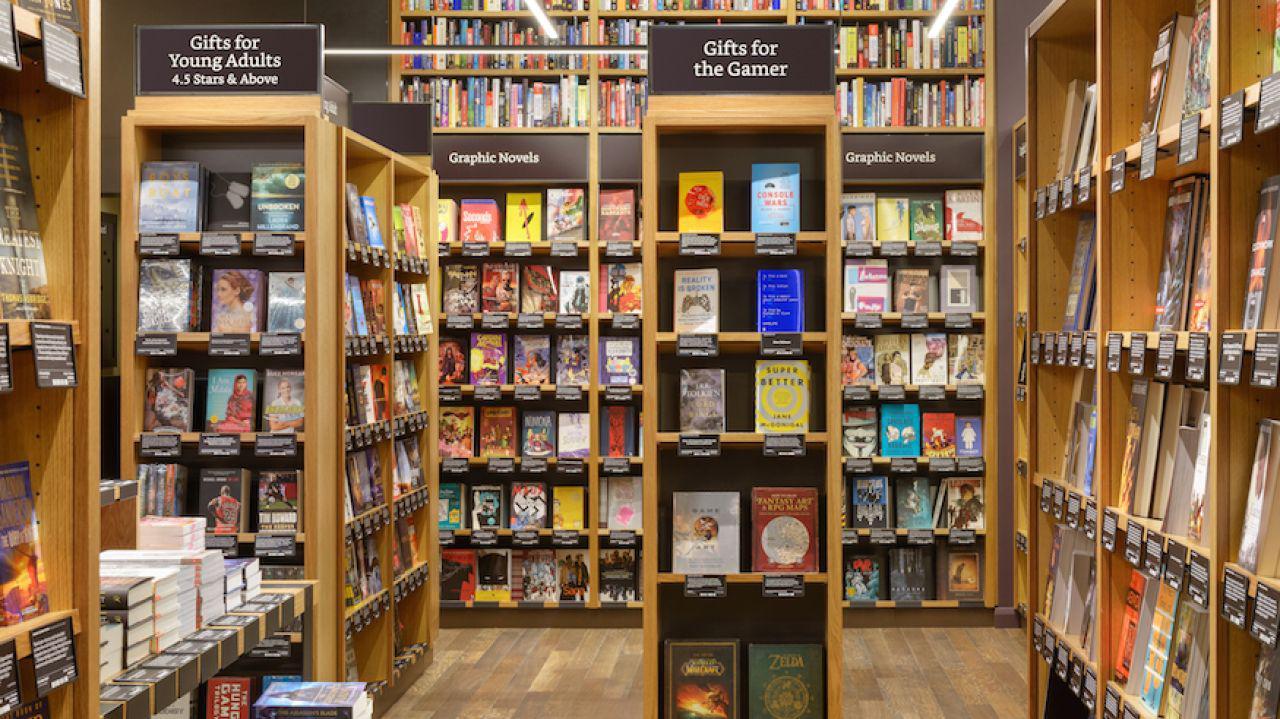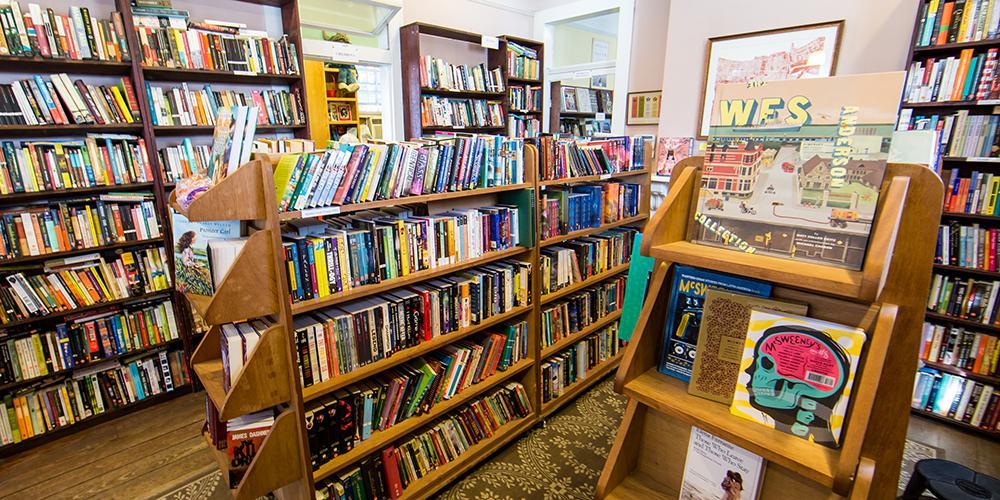The first image is the image on the left, the second image is the image on the right. Considering the images on both sides, is "No one is visible in the bookstore in the left." valid? Answer yes or no. Yes. The first image is the image on the left, the second image is the image on the right. For the images shown, is this caption "Suspended non-tube-shaped lights are visible in at least one bookstore image." true? Answer yes or no. No. 